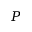<formula> <loc_0><loc_0><loc_500><loc_500>P</formula> 